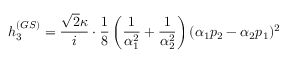<formula> <loc_0><loc_0><loc_500><loc_500>h _ { 3 } ^ { ( G S ) } = \frac { \sqrt { 2 } \kappa } { i } \cdot \frac { 1 } { 8 } \left ( \frac { 1 } { \alpha _ { 1 } ^ { 2 } } + \frac { 1 } { \alpha _ { 2 } ^ { 2 } } \right ) ( \alpha _ { 1 } p _ { 2 } - \alpha _ { 2 } p _ { 1 } ) ^ { 2 }</formula> 